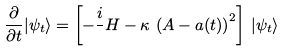Convert formula to latex. <formula><loc_0><loc_0><loc_500><loc_500>\frac { \partial } { \partial t } | \psi _ { t } \rangle = \left [ - \frac { i } { } H - \kappa \, \left ( A - a ( t ) \right ) ^ { 2 } \right ] \, | \psi _ { t } \rangle</formula> 